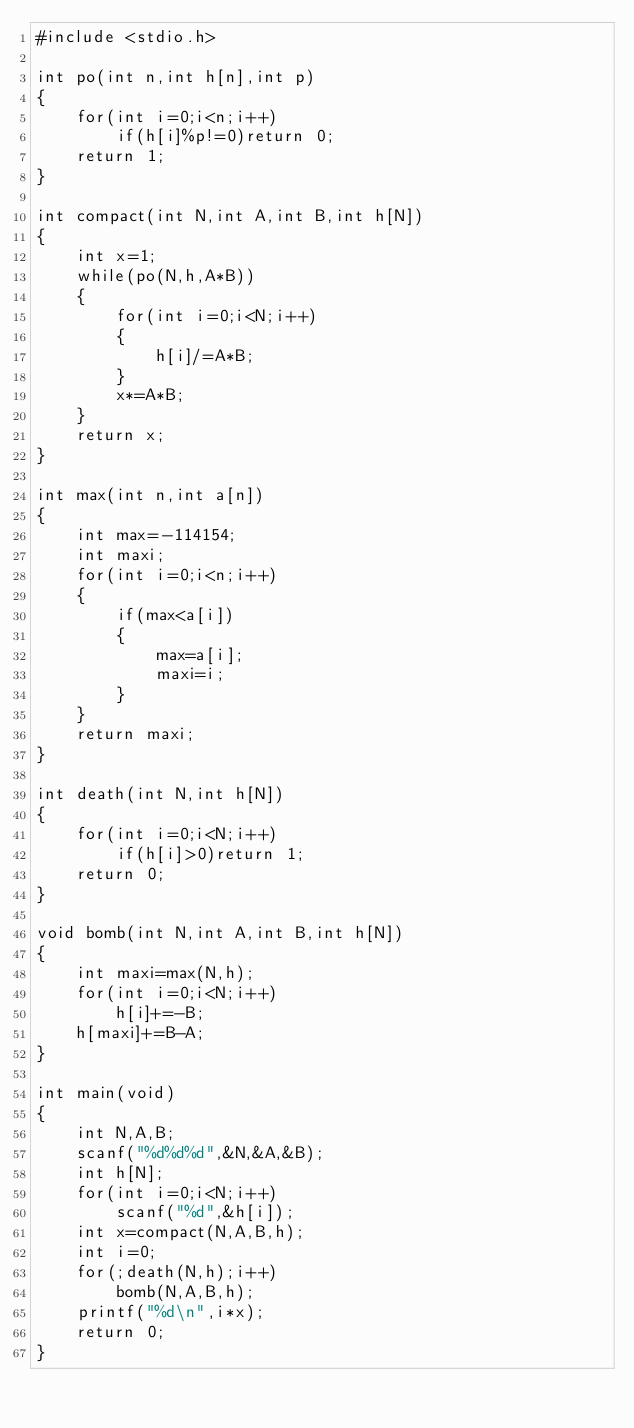<code> <loc_0><loc_0><loc_500><loc_500><_C_>#include <stdio.h>

int po(int n,int h[n],int p)
{
	for(int i=0;i<n;i++)
		if(h[i]%p!=0)return 0;
	return 1;
}

int compact(int N,int A,int B,int h[N])
{
	int x=1;
	while(po(N,h,A*B))
	{
		for(int i=0;i<N;i++)
		{
			h[i]/=A*B;
		}
		x*=A*B;
	}
	return x;
}

int max(int n,int a[n])
{
	int max=-114154;
	int maxi;
	for(int i=0;i<n;i++)
	{
		if(max<a[i])
		{
			max=a[i];
			maxi=i;
		}
	}
	return maxi;
}

int death(int N,int h[N])
{
	for(int i=0;i<N;i++)
		if(h[i]>0)return 1;
	return 0;
}

void bomb(int N,int A,int B,int h[N])
{
	int maxi=max(N,h);
	for(int i=0;i<N;i++)
		h[i]+=-B;
	h[maxi]+=B-A;
}

int main(void)
{
	int N,A,B;
	scanf("%d%d%d",&N,&A,&B);
	int h[N];
	for(int i=0;i<N;i++)
		scanf("%d",&h[i]);
	int x=compact(N,A,B,h);
	int i=0;
	for(;death(N,h);i++)
		bomb(N,A,B,h);
	printf("%d\n",i*x);
	return 0;
}
</code> 